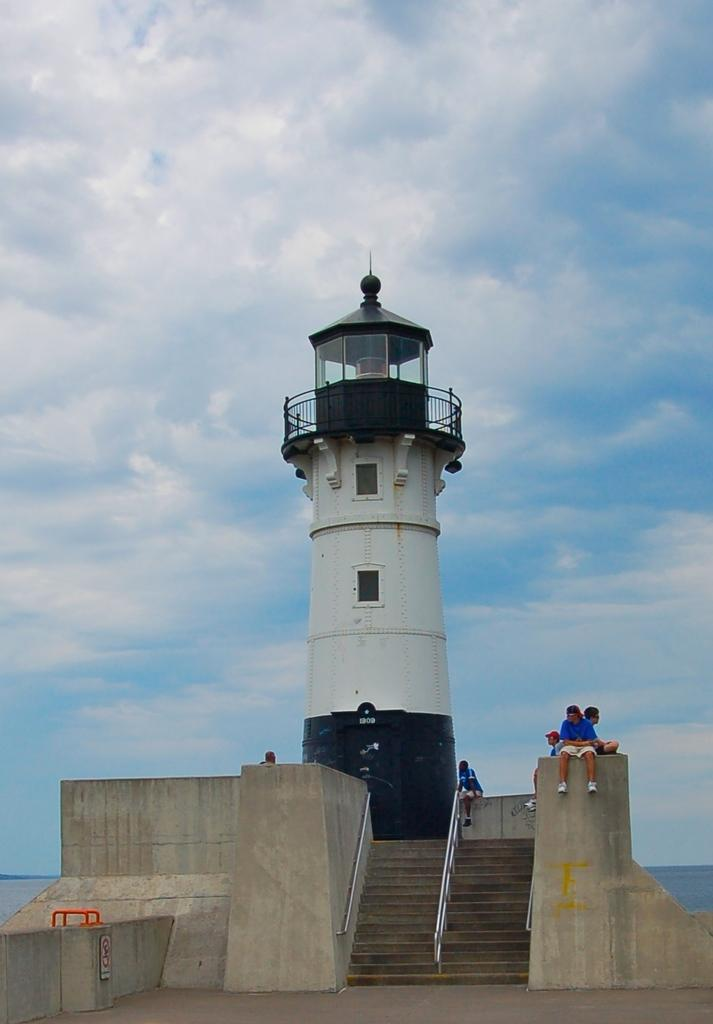What type of structure is in the image? There is a concrete structure in the image. What are the people in the image doing? The people are sitting on the wall in the image. What other notable feature can be seen in the image? There is a lighthouse in the image. What can be seen in the background of the image? The sky is visible in the background of the image, and clouds are present. How do the people in the image say good-bye to each other? There is no indication in the image that the people are saying good-bye to each other. What type of cap is the lighthouse wearing in the image? The lighthouse is not wearing a cap; it is a structure with a light on top. 